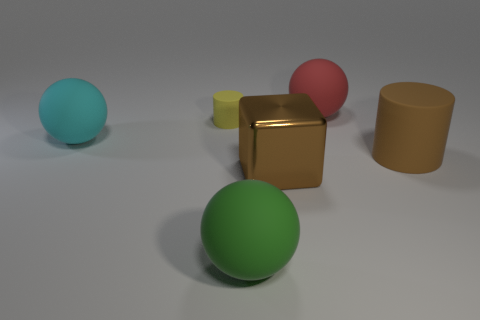Does the object in front of the large metallic cube have the same size as the matte ball on the left side of the large green matte thing?
Provide a short and direct response. Yes. Is there a big cube made of the same material as the yellow object?
Give a very brief answer. No. What number of things are big rubber spheres behind the brown matte cylinder or tiny gray rubber blocks?
Ensure brevity in your answer.  2. Do the ball in front of the large brown matte thing and the brown block have the same material?
Your answer should be compact. No. Do the big red rubber thing and the large cyan object have the same shape?
Provide a succinct answer. Yes. There is a matte sphere behind the tiny thing; what number of large brown metal blocks are in front of it?
Your response must be concise. 1. Is the color of the cylinder in front of the small cylinder the same as the tiny rubber cylinder?
Give a very brief answer. No. Does the block have the same material as the cylinder that is left of the big brown rubber object?
Provide a succinct answer. No. What shape is the large rubber object behind the tiny object?
Provide a succinct answer. Sphere. How many other objects are there of the same material as the large brown block?
Provide a short and direct response. 0. 